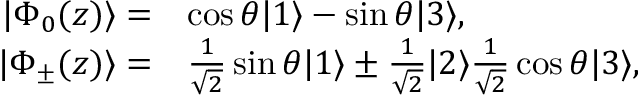Convert formula to latex. <formula><loc_0><loc_0><loc_500><loc_500>\begin{array} { r } { \begin{array} { r l } { | \Phi _ { 0 } ( z ) \rangle = } & { \cos \theta | 1 \rangle - \sin \theta | 3 \rangle , } \\ { | \Phi _ { \pm } ( z ) \rangle = } & { \frac { 1 } { \sqrt { 2 } } \sin \theta | 1 \rangle \pm \frac { 1 } { \sqrt { 2 } } | 2 \rangle \frac { 1 } { \sqrt { 2 } } \cos \theta | 3 \rangle , } \end{array} } \end{array}</formula> 